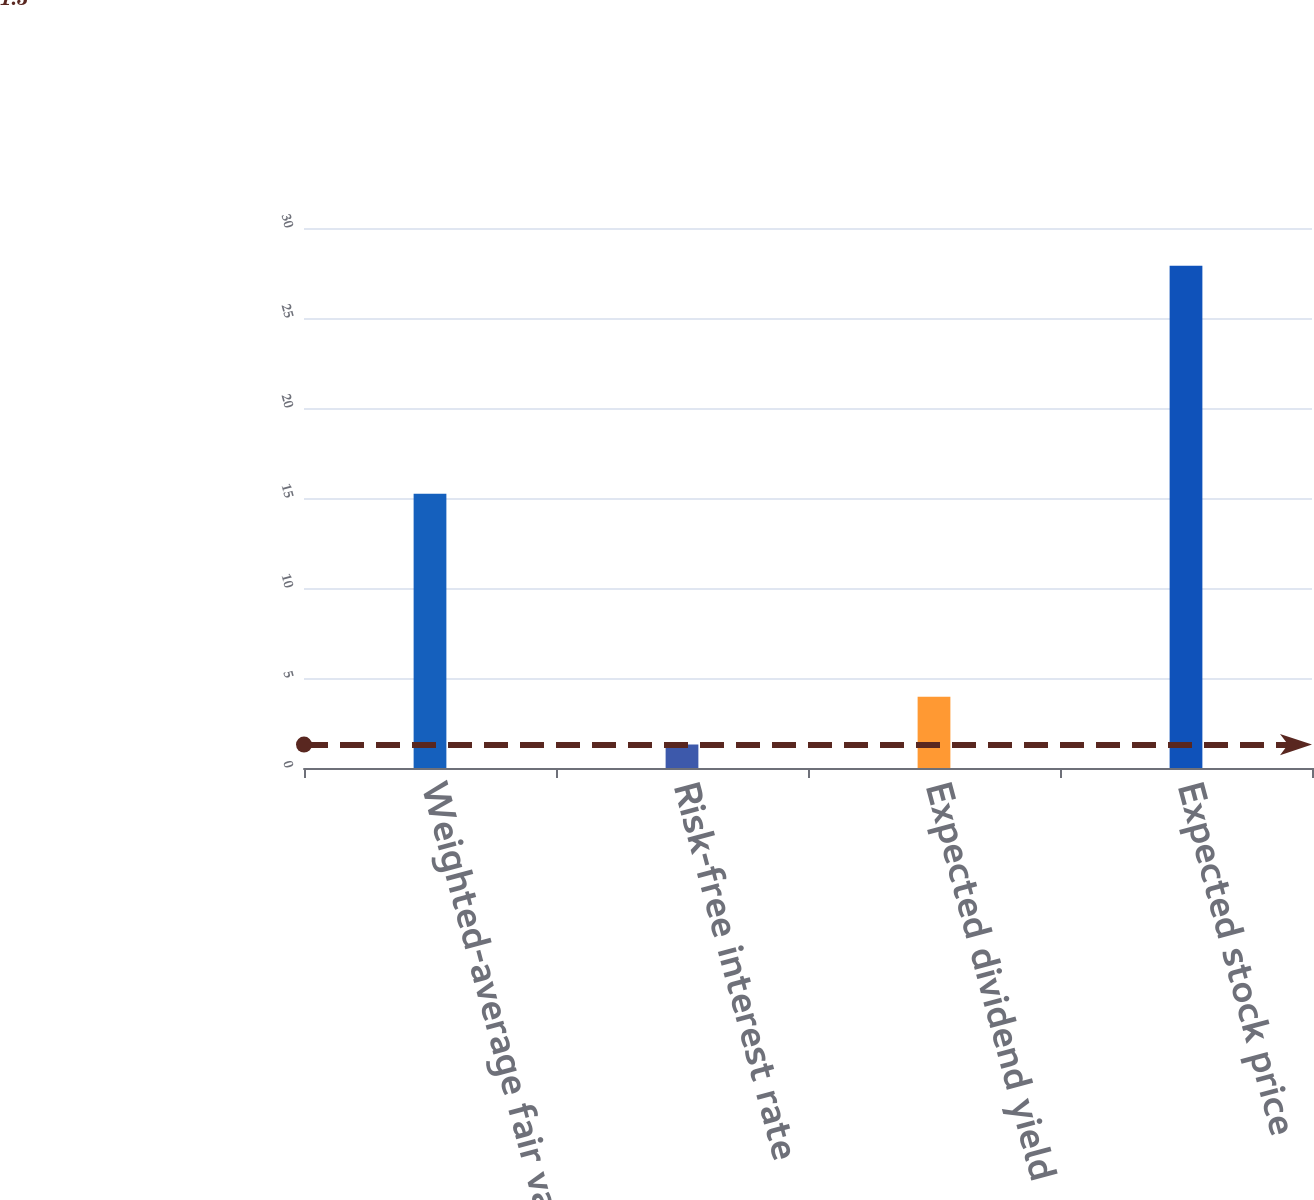Convert chart. <chart><loc_0><loc_0><loc_500><loc_500><bar_chart><fcel>Weighted-average fair value<fcel>Risk-free interest rate<fcel>Expected dividend yield<fcel>Expected stock price<nl><fcel>15.24<fcel>1.3<fcel>3.96<fcel>27.9<nl></chart> 